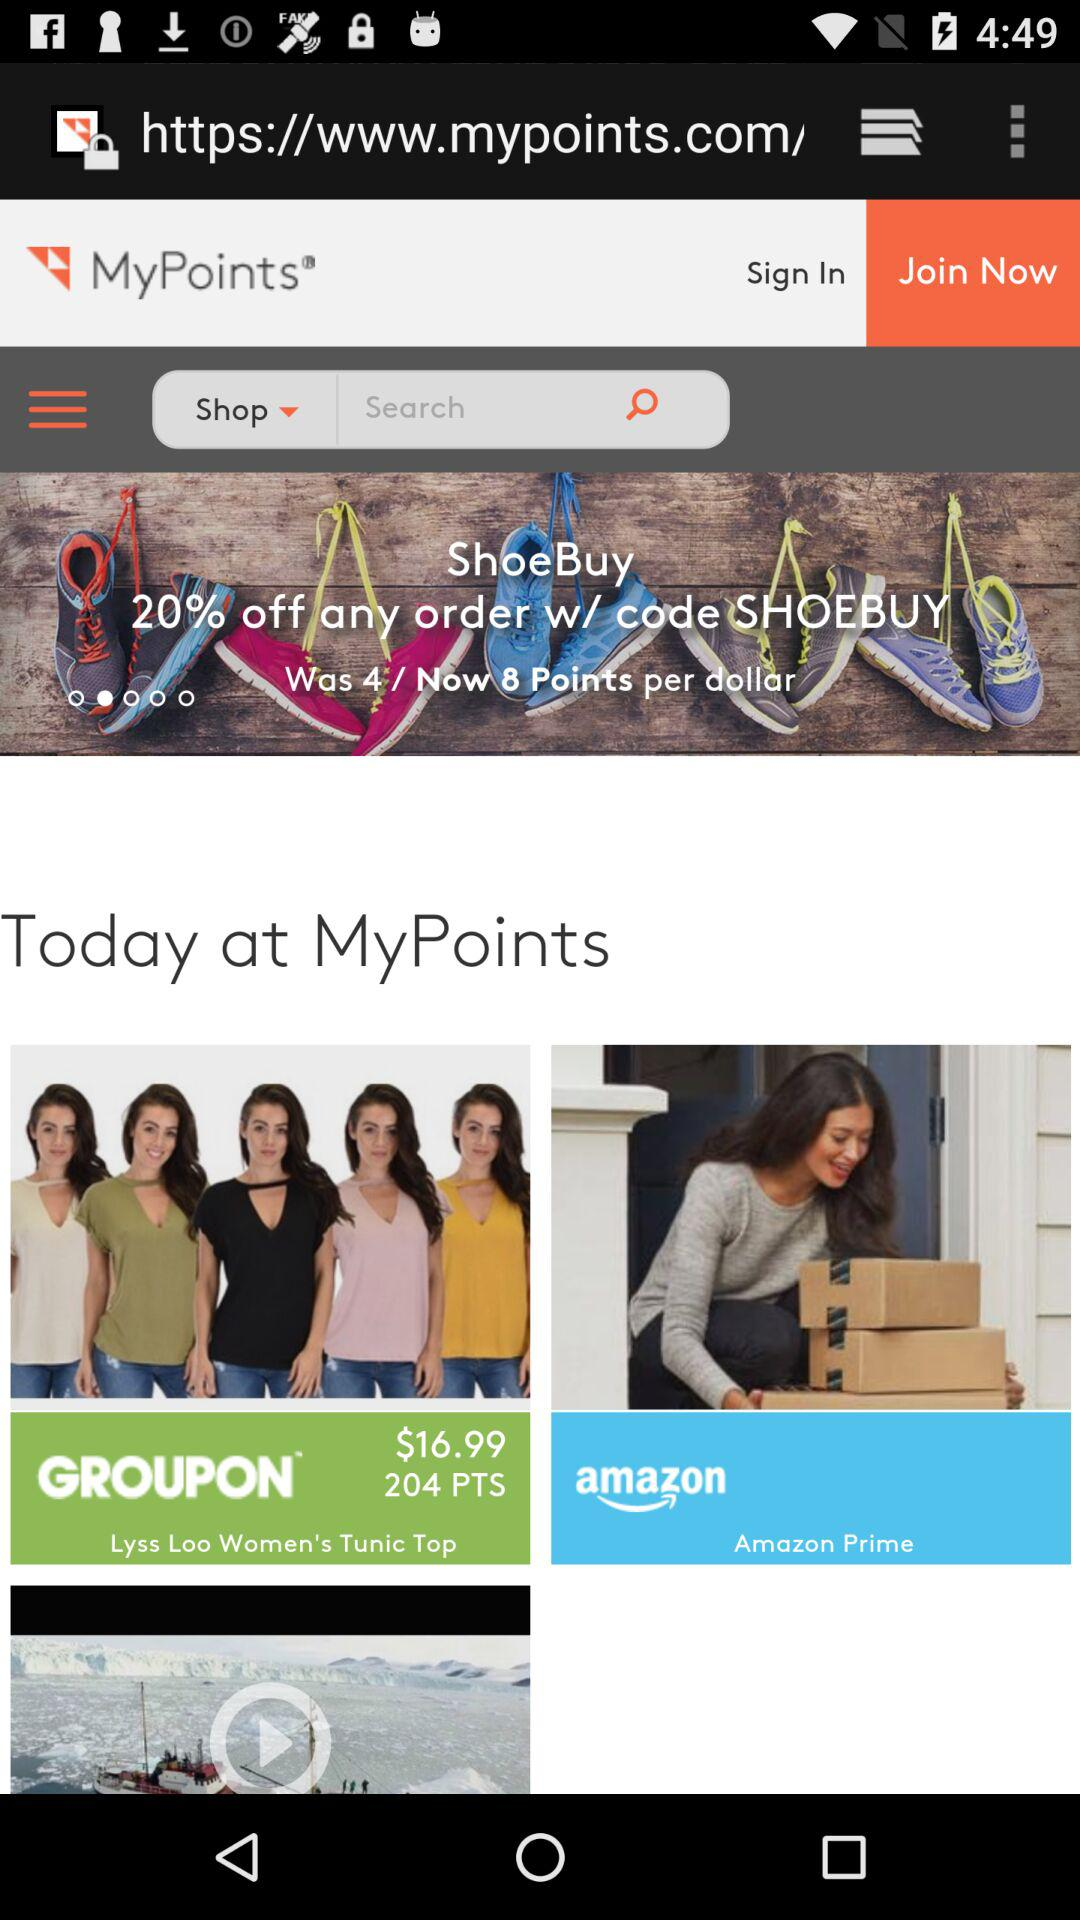What is the total number of points in "GROUPON"? The total number of points in "GROUPON" is 204. 